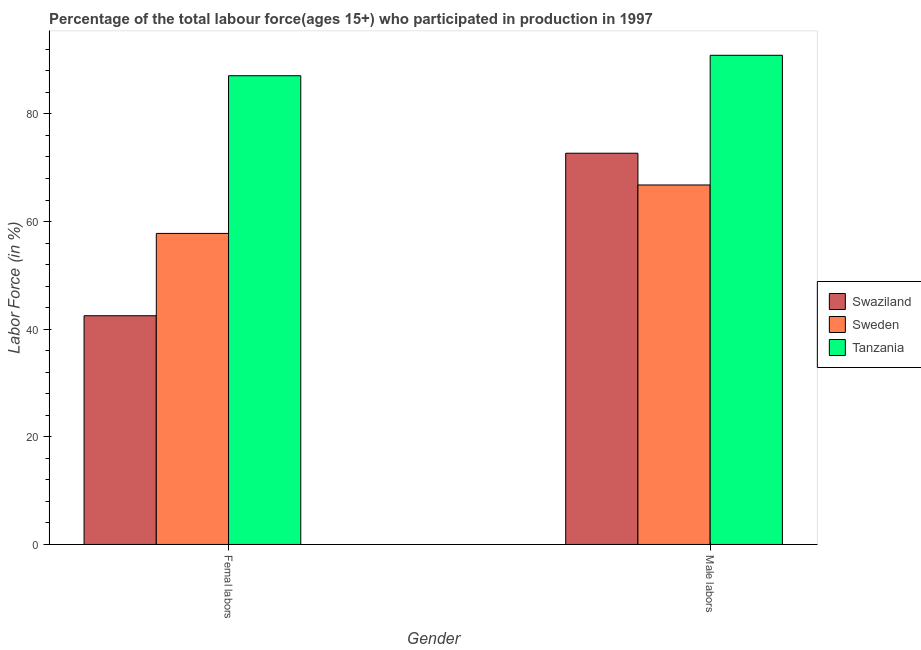How many different coloured bars are there?
Ensure brevity in your answer.  3. Are the number of bars on each tick of the X-axis equal?
Keep it short and to the point. Yes. How many bars are there on the 1st tick from the left?
Give a very brief answer. 3. How many bars are there on the 1st tick from the right?
Your answer should be very brief. 3. What is the label of the 1st group of bars from the left?
Your response must be concise. Femal labors. What is the percentage of male labour force in Tanzania?
Your answer should be very brief. 90.9. Across all countries, what is the maximum percentage of female labor force?
Keep it short and to the point. 87.1. Across all countries, what is the minimum percentage of female labor force?
Your answer should be compact. 42.5. In which country was the percentage of female labor force maximum?
Offer a very short reply. Tanzania. In which country was the percentage of female labor force minimum?
Keep it short and to the point. Swaziland. What is the total percentage of female labor force in the graph?
Offer a terse response. 187.4. What is the difference between the percentage of male labour force in Sweden and that in Swaziland?
Your answer should be compact. -5.9. What is the difference between the percentage of male labour force in Tanzania and the percentage of female labor force in Swaziland?
Provide a short and direct response. 48.4. What is the average percentage of male labour force per country?
Provide a succinct answer. 76.8. What is the difference between the percentage of female labor force and percentage of male labour force in Swaziland?
Your answer should be very brief. -30.2. In how many countries, is the percentage of female labor force greater than 64 %?
Offer a terse response. 1. What is the ratio of the percentage of male labour force in Tanzania to that in Sweden?
Offer a terse response. 1.36. What does the 1st bar from the left in Male labors represents?
Your answer should be very brief. Swaziland. What does the 1st bar from the right in Femal labors represents?
Ensure brevity in your answer.  Tanzania. Are all the bars in the graph horizontal?
Ensure brevity in your answer.  No. What is the difference between two consecutive major ticks on the Y-axis?
Offer a very short reply. 20. Are the values on the major ticks of Y-axis written in scientific E-notation?
Offer a very short reply. No. Where does the legend appear in the graph?
Your answer should be very brief. Center right. How are the legend labels stacked?
Give a very brief answer. Vertical. What is the title of the graph?
Give a very brief answer. Percentage of the total labour force(ages 15+) who participated in production in 1997. Does "Turks and Caicos Islands" appear as one of the legend labels in the graph?
Make the answer very short. No. What is the label or title of the X-axis?
Offer a terse response. Gender. What is the label or title of the Y-axis?
Ensure brevity in your answer.  Labor Force (in %). What is the Labor Force (in %) in Swaziland in Femal labors?
Give a very brief answer. 42.5. What is the Labor Force (in %) in Sweden in Femal labors?
Provide a succinct answer. 57.8. What is the Labor Force (in %) of Tanzania in Femal labors?
Ensure brevity in your answer.  87.1. What is the Labor Force (in %) of Swaziland in Male labors?
Offer a terse response. 72.7. What is the Labor Force (in %) in Sweden in Male labors?
Offer a terse response. 66.8. What is the Labor Force (in %) of Tanzania in Male labors?
Provide a short and direct response. 90.9. Across all Gender, what is the maximum Labor Force (in %) in Swaziland?
Offer a terse response. 72.7. Across all Gender, what is the maximum Labor Force (in %) of Sweden?
Ensure brevity in your answer.  66.8. Across all Gender, what is the maximum Labor Force (in %) of Tanzania?
Provide a succinct answer. 90.9. Across all Gender, what is the minimum Labor Force (in %) of Swaziland?
Make the answer very short. 42.5. Across all Gender, what is the minimum Labor Force (in %) of Sweden?
Your answer should be very brief. 57.8. Across all Gender, what is the minimum Labor Force (in %) of Tanzania?
Ensure brevity in your answer.  87.1. What is the total Labor Force (in %) in Swaziland in the graph?
Provide a succinct answer. 115.2. What is the total Labor Force (in %) of Sweden in the graph?
Provide a succinct answer. 124.6. What is the total Labor Force (in %) in Tanzania in the graph?
Keep it short and to the point. 178. What is the difference between the Labor Force (in %) of Swaziland in Femal labors and that in Male labors?
Your answer should be very brief. -30.2. What is the difference between the Labor Force (in %) of Sweden in Femal labors and that in Male labors?
Provide a short and direct response. -9. What is the difference between the Labor Force (in %) of Swaziland in Femal labors and the Labor Force (in %) of Sweden in Male labors?
Offer a terse response. -24.3. What is the difference between the Labor Force (in %) in Swaziland in Femal labors and the Labor Force (in %) in Tanzania in Male labors?
Offer a terse response. -48.4. What is the difference between the Labor Force (in %) in Sweden in Femal labors and the Labor Force (in %) in Tanzania in Male labors?
Provide a short and direct response. -33.1. What is the average Labor Force (in %) in Swaziland per Gender?
Make the answer very short. 57.6. What is the average Labor Force (in %) in Sweden per Gender?
Ensure brevity in your answer.  62.3. What is the average Labor Force (in %) of Tanzania per Gender?
Provide a short and direct response. 89. What is the difference between the Labor Force (in %) of Swaziland and Labor Force (in %) of Sweden in Femal labors?
Make the answer very short. -15.3. What is the difference between the Labor Force (in %) in Swaziland and Labor Force (in %) in Tanzania in Femal labors?
Give a very brief answer. -44.6. What is the difference between the Labor Force (in %) of Sweden and Labor Force (in %) of Tanzania in Femal labors?
Your response must be concise. -29.3. What is the difference between the Labor Force (in %) of Swaziland and Labor Force (in %) of Tanzania in Male labors?
Provide a succinct answer. -18.2. What is the difference between the Labor Force (in %) of Sweden and Labor Force (in %) of Tanzania in Male labors?
Make the answer very short. -24.1. What is the ratio of the Labor Force (in %) of Swaziland in Femal labors to that in Male labors?
Your response must be concise. 0.58. What is the ratio of the Labor Force (in %) of Sweden in Femal labors to that in Male labors?
Your answer should be very brief. 0.87. What is the ratio of the Labor Force (in %) in Tanzania in Femal labors to that in Male labors?
Offer a terse response. 0.96. What is the difference between the highest and the second highest Labor Force (in %) of Swaziland?
Offer a very short reply. 30.2. What is the difference between the highest and the second highest Labor Force (in %) in Tanzania?
Give a very brief answer. 3.8. What is the difference between the highest and the lowest Labor Force (in %) of Swaziland?
Offer a terse response. 30.2. 